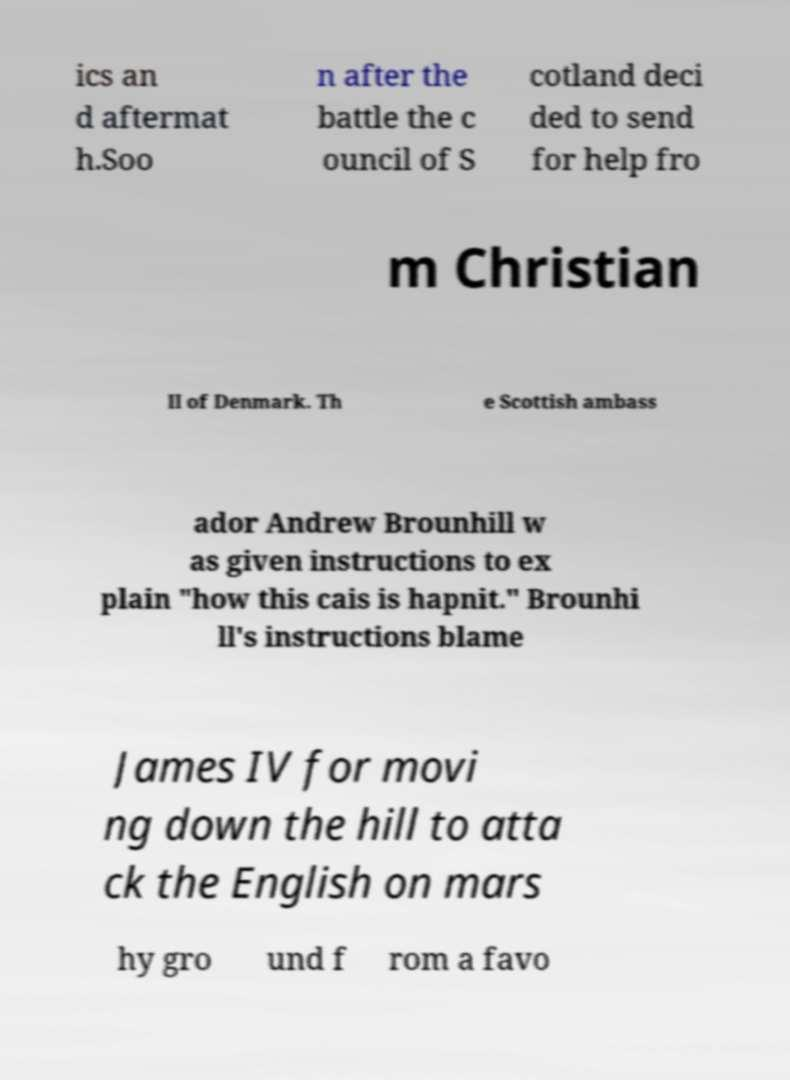For documentation purposes, I need the text within this image transcribed. Could you provide that? ics an d aftermat h.Soo n after the battle the c ouncil of S cotland deci ded to send for help fro m Christian II of Denmark. Th e Scottish ambass ador Andrew Brounhill w as given instructions to ex plain "how this cais is hapnit." Brounhi ll's instructions blame James IV for movi ng down the hill to atta ck the English on mars hy gro und f rom a favo 